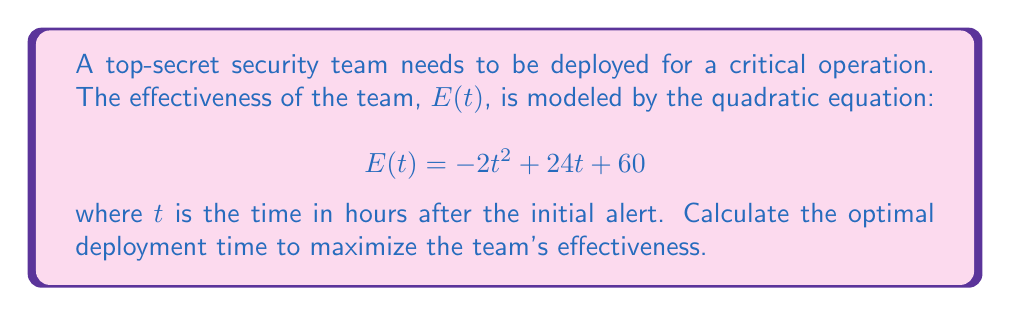Provide a solution to this math problem. To find the optimal deployment time, we need to determine the maximum point of the quadratic function. This can be done by following these steps:

1) The quadratic function is in the form $f(t) = at^2 + bt + c$, where $a = -2$, $b = 24$, and $c = 60$.

2) For a quadratic function, the t-coordinate of the vertex (which represents the optimal time in this case) is given by the formula:

   $$t = -\frac{b}{2a}$$

3) Substituting our values:

   $$t = -\frac{24}{2(-2)} = -\frac{24}{-4} = 6$$

4) To verify this is a maximum (not a minimum), we can check that $a < 0$, which it is ($a = -2$).

5) Therefore, the optimal deployment time is 6 hours after the initial alert.

6) We can calculate the maximum effectiveness by plugging t = 6 into the original equation:

   $$E(6) = -2(6)^2 + 24(6) + 60$$
   $$= -2(36) + 144 + 60$$
   $$= -72 + 144 + 60$$
   $$= 132$$

Thus, the maximum effectiveness is 132 units.
Answer: The optimal deployment time is 6 hours after the initial alert, resulting in a maximum effectiveness of 132 units. 